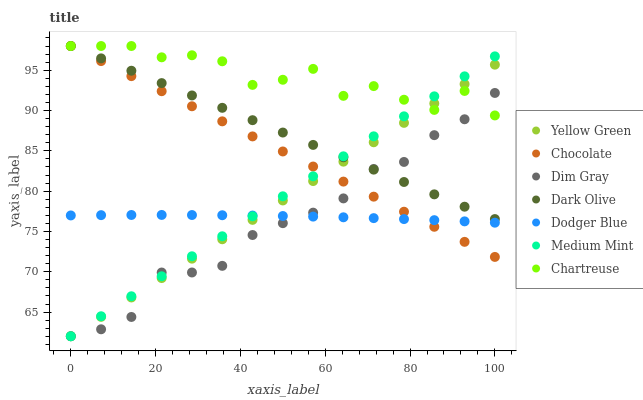Does Dim Gray have the minimum area under the curve?
Answer yes or no. Yes. Does Chartreuse have the maximum area under the curve?
Answer yes or no. Yes. Does Yellow Green have the minimum area under the curve?
Answer yes or no. No. Does Yellow Green have the maximum area under the curve?
Answer yes or no. No. Is Chocolate the smoothest?
Answer yes or no. Yes. Is Chartreuse the roughest?
Answer yes or no. Yes. Is Dim Gray the smoothest?
Answer yes or no. No. Is Dim Gray the roughest?
Answer yes or no. No. Does Medium Mint have the lowest value?
Answer yes or no. Yes. Does Dark Olive have the lowest value?
Answer yes or no. No. Does Chartreuse have the highest value?
Answer yes or no. Yes. Does Dim Gray have the highest value?
Answer yes or no. No. Is Dodger Blue less than Dark Olive?
Answer yes or no. Yes. Is Dark Olive greater than Dodger Blue?
Answer yes or no. Yes. Does Dim Gray intersect Dark Olive?
Answer yes or no. Yes. Is Dim Gray less than Dark Olive?
Answer yes or no. No. Is Dim Gray greater than Dark Olive?
Answer yes or no. No. Does Dodger Blue intersect Dark Olive?
Answer yes or no. No. 